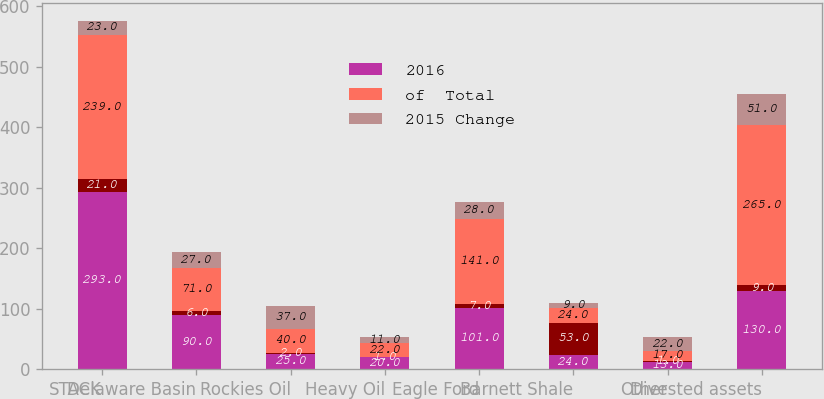<chart> <loc_0><loc_0><loc_500><loc_500><stacked_bar_chart><ecel><fcel>STACK<fcel>Delaware Basin<fcel>Rockies Oil<fcel>Heavy Oil<fcel>Eagle Ford<fcel>Barnett Shale<fcel>Other<fcel>Divested assets<nl><fcel>2016<fcel>293<fcel>90<fcel>25<fcel>20<fcel>101<fcel>24<fcel>13<fcel>130<nl><fcel>nan<fcel>21<fcel>6<fcel>2<fcel>1<fcel>7<fcel>53<fcel>1<fcel>9<nl><fcel>of  Total<fcel>239<fcel>71<fcel>40<fcel>22<fcel>141<fcel>24<fcel>17<fcel>265<nl><fcel>2015 Change<fcel>23<fcel>27<fcel>37<fcel>11<fcel>28<fcel>9<fcel>22<fcel>51<nl></chart> 